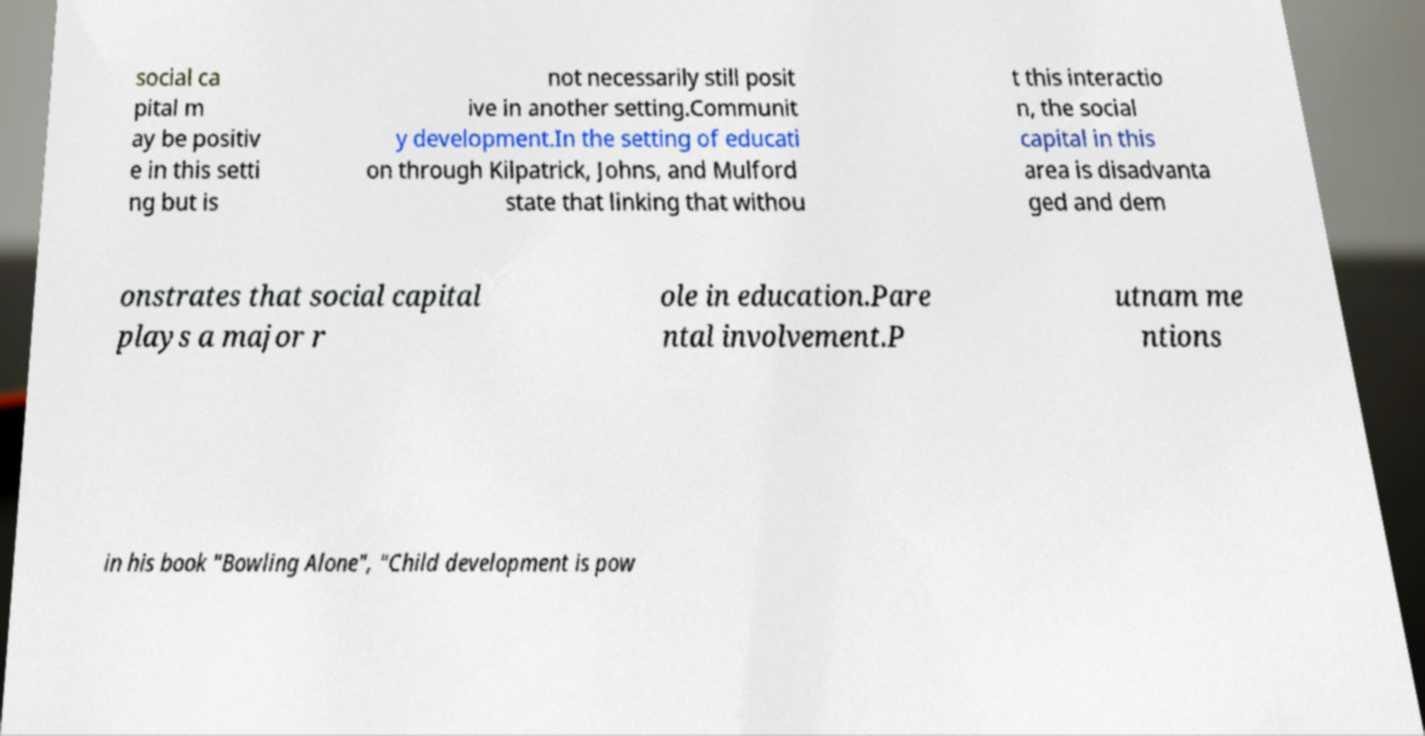I need the written content from this picture converted into text. Can you do that? social ca pital m ay be positiv e in this setti ng but is not necessarily still posit ive in another setting.Communit y development.In the setting of educati on through Kilpatrick, Johns, and Mulford state that linking that withou t this interactio n, the social capital in this area is disadvanta ged and dem onstrates that social capital plays a major r ole in education.Pare ntal involvement.P utnam me ntions in his book "Bowling Alone", "Child development is pow 